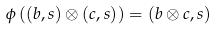<formula> <loc_0><loc_0><loc_500><loc_500>\phi \left ( ( b , s ) \otimes ( c , s ) \right ) = ( b \otimes c , s )</formula> 